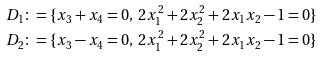Convert formula to latex. <formula><loc_0><loc_0><loc_500><loc_500>D _ { 1 } & \colon = \{ x _ { 3 } + x _ { 4 } = 0 , \ 2 x _ { 1 } ^ { 2 } + 2 x _ { 2 } ^ { 2 } + 2 x _ { 1 } x _ { 2 } - 1 = 0 \} \\ D _ { 2 } & \colon = \{ x _ { 3 } - x _ { 4 } = 0 , \ 2 x _ { 1 } ^ { 2 } + 2 x _ { 2 } ^ { 2 } + 2 x _ { 1 } x _ { 2 } - 1 = 0 \}</formula> 